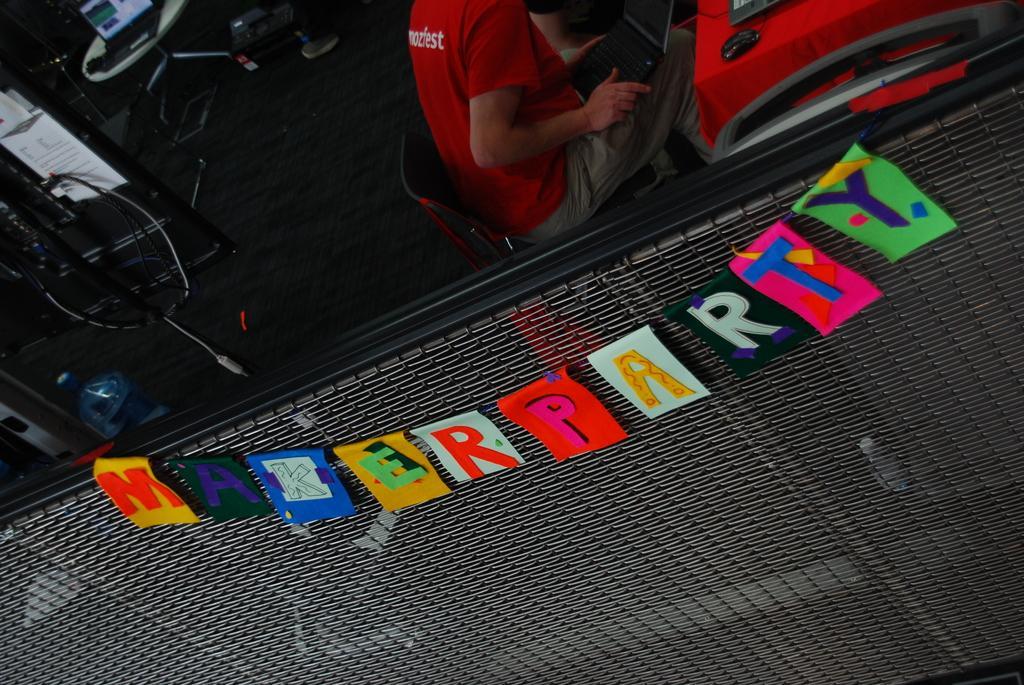Can you describe this image briefly? In this picture I can observe some letters on the papers. The papers are in yellow, green, blue, black and white colors. They are tied to the fence. I can observe a person sitting in the chair on the top of the picture. On the left side I can observe a laptop placed on the table. On the right side there is a red color table cloth and a mouse on the table. 